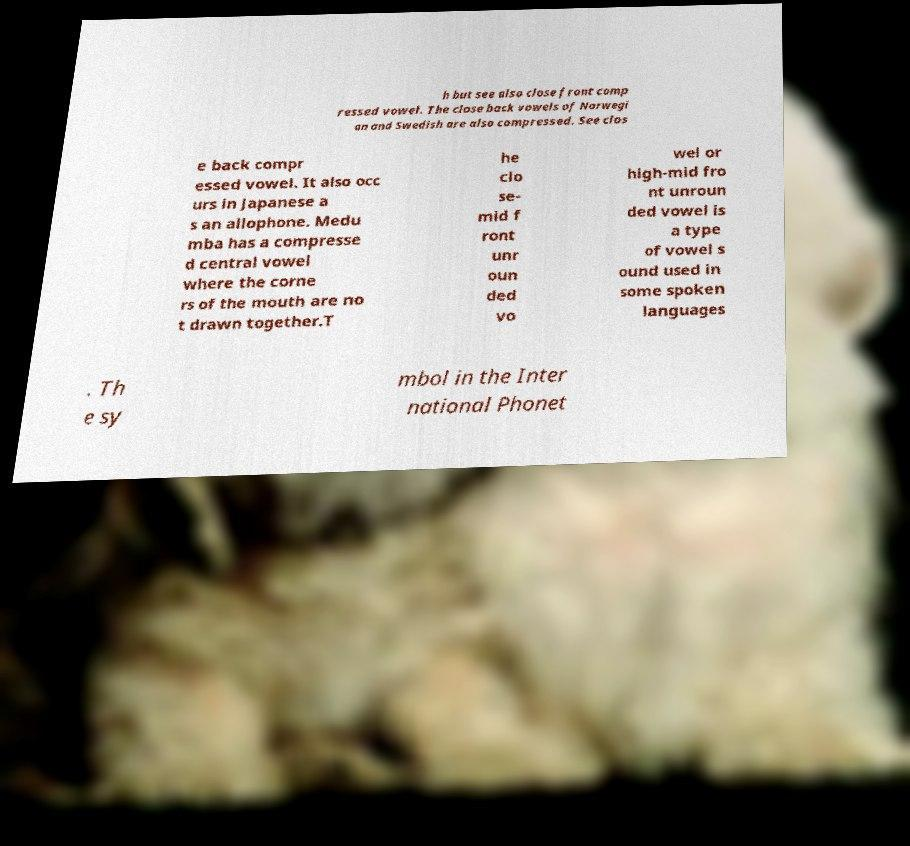For documentation purposes, I need the text within this image transcribed. Could you provide that? h but see also close front comp ressed vowel. The close back vowels of Norwegi an and Swedish are also compressed. See clos e back compr essed vowel. It also occ urs in Japanese a s an allophone. Medu mba has a compresse d central vowel where the corne rs of the mouth are no t drawn together.T he clo se- mid f ront unr oun ded vo wel or high-mid fro nt unroun ded vowel is a type of vowel s ound used in some spoken languages . Th e sy mbol in the Inter national Phonet 